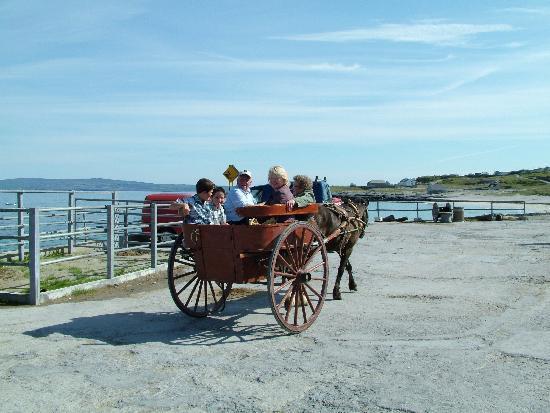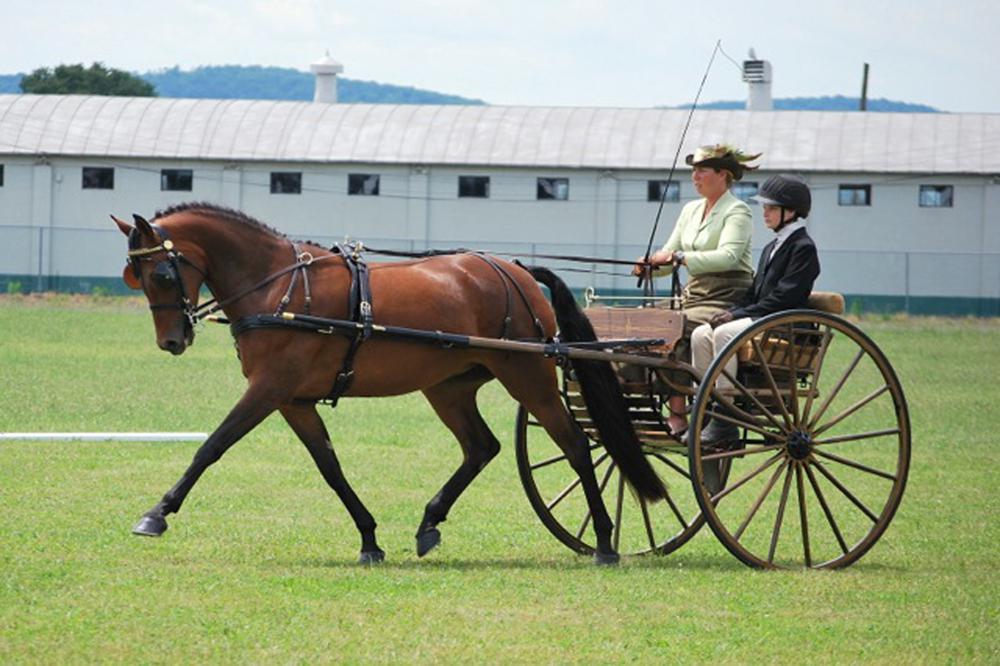The first image is the image on the left, the second image is the image on the right. Analyze the images presented: Is the assertion "The wheels on each of the carts are spoked wooden ones ." valid? Answer yes or no. Yes. The first image is the image on the left, the second image is the image on the right. Given the left and right images, does the statement "An image shows at least one member of a wedding party in the back of a four-wheeled carriage heading away from the camera." hold true? Answer yes or no. No. 